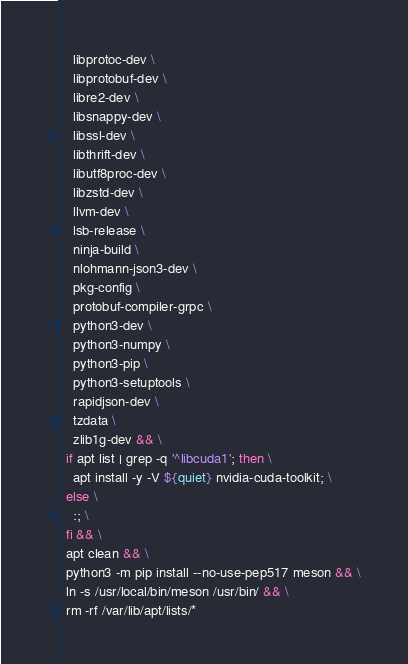<code> <loc_0><loc_0><loc_500><loc_500><_Dockerfile_>    libprotoc-dev \
    libprotobuf-dev \
    libre2-dev \
    libsnappy-dev \
    libssl-dev \
    libthrift-dev \
    libutf8proc-dev \
    libzstd-dev \
    llvm-dev \
    lsb-release \
    ninja-build \
    nlohmann-json3-dev \
    pkg-config \
    protobuf-compiler-grpc \
    python3-dev \
    python3-numpy \
    python3-pip \
    python3-setuptools \
    rapidjson-dev \
    tzdata \
    zlib1g-dev && \
  if apt list | grep -q '^libcuda1'; then \
    apt install -y -V ${quiet} nvidia-cuda-toolkit; \
  else \
    :; \
  fi && \
  apt clean && \
  python3 -m pip install --no-use-pep517 meson && \
  ln -s /usr/local/bin/meson /usr/bin/ && \
  rm -rf /var/lib/apt/lists/*
</code> 